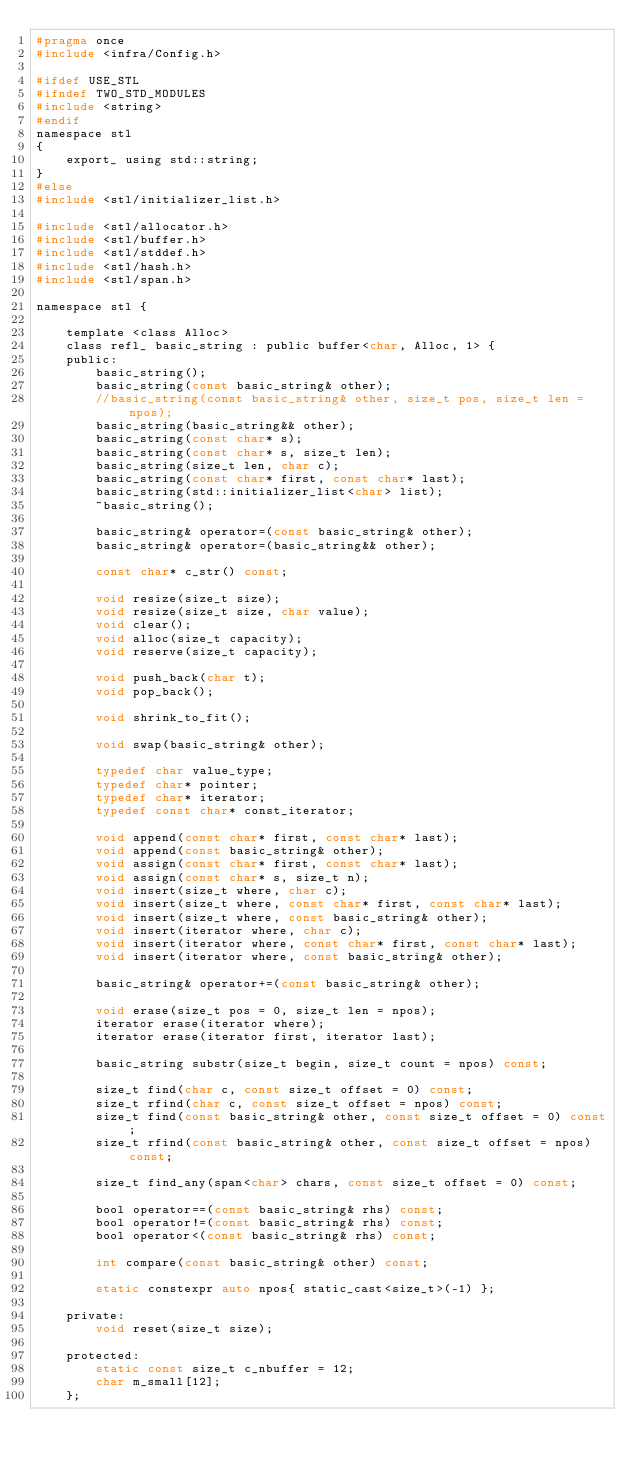<code> <loc_0><loc_0><loc_500><loc_500><_C_>#pragma once
#include <infra/Config.h>

#ifdef USE_STL
#ifndef TWO_STD_MODULES
#include <string>
#endif
namespace stl
{
	export_ using std::string;
}
#else
#include <stl/initializer_list.h>

#include <stl/allocator.h>
#include <stl/buffer.h>
#include <stl/stddef.h>
#include <stl/hash.h>
#include <stl/span.h>

namespace stl {

	template <class Alloc>
	class refl_ basic_string : public buffer<char, Alloc, 1> {
	public:
		basic_string();
		basic_string(const basic_string& other);
		//basic_string(const basic_string& other, size_t pos, size_t len = npos);
		basic_string(basic_string&& other);
		basic_string(const char* s);
		basic_string(const char* s, size_t len);
		basic_string(size_t len, char c);
		basic_string(const char* first, const char* last);
		basic_string(std::initializer_list<char> list);
		~basic_string();

		basic_string& operator=(const basic_string& other);
		basic_string& operator=(basic_string&& other);

		const char* c_str() const;

		void resize(size_t size);
		void resize(size_t size, char value);
		void clear();
		void alloc(size_t capacity);
		void reserve(size_t capacity);

		void push_back(char t);
		void pop_back();

		void shrink_to_fit();

		void swap(basic_string& other);

		typedef char value_type;
		typedef char* pointer;
		typedef char* iterator;
		typedef const char* const_iterator;

		void append(const char* first, const char* last);
		void append(const basic_string& other);
		void assign(const char* first, const char* last);
		void assign(const char* s, size_t n);
		void insert(size_t where, char c);
		void insert(size_t where, const char* first, const char* last);
		void insert(size_t where, const basic_string& other);
		void insert(iterator where, char c);
		void insert(iterator where, const char* first, const char* last);
		void insert(iterator where, const basic_string& other);

		basic_string& operator+=(const basic_string& other);

		void erase(size_t pos = 0, size_t len = npos);
		iterator erase(iterator where);
		iterator erase(iterator first, iterator last);

		basic_string substr(size_t begin, size_t count = npos) const;

		size_t find(char c, const size_t offset = 0) const;
		size_t rfind(char c, const size_t offset = npos) const;
		size_t find(const basic_string& other, const size_t offset = 0) const;
		size_t rfind(const basic_string& other, const size_t offset = npos) const;

		size_t find_any(span<char> chars, const size_t offset = 0) const;

		bool operator==(const basic_string& rhs) const;
		bool operator!=(const basic_string& rhs) const;
		bool operator<(const basic_string& rhs) const;

		int compare(const basic_string& other) const;

		static constexpr auto npos{ static_cast<size_t>(-1) };

	private:
		void reset(size_t size);

	protected:
		static const size_t c_nbuffer = 12;
		char m_small[12];
	};
</code> 